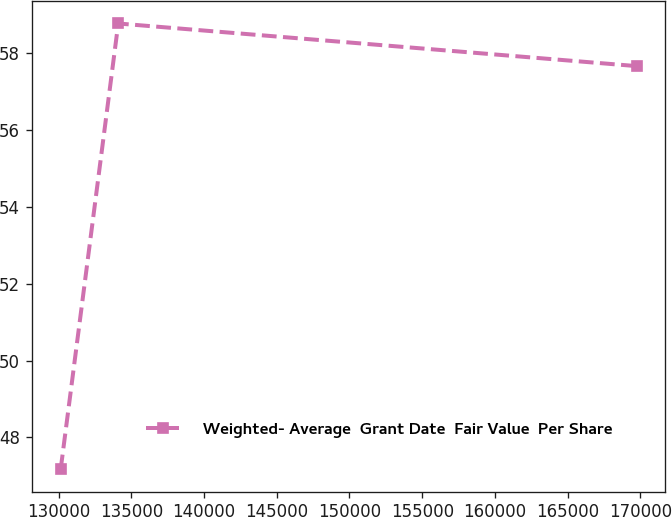<chart> <loc_0><loc_0><loc_500><loc_500><line_chart><ecel><fcel>Weighted- Average  Grant Date  Fair Value  Per Share<nl><fcel>130145<fcel>47.17<nl><fcel>134104<fcel>58.78<nl><fcel>169737<fcel>57.67<nl></chart> 